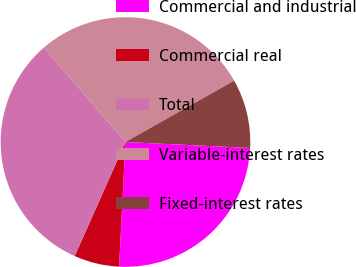Convert chart. <chart><loc_0><loc_0><loc_500><loc_500><pie_chart><fcel>Commercial and industrial<fcel>Commercial real<fcel>Total<fcel>Variable-interest rates<fcel>Fixed-interest rates<nl><fcel>25.06%<fcel>5.85%<fcel>31.99%<fcel>28.16%<fcel>8.94%<nl></chart> 